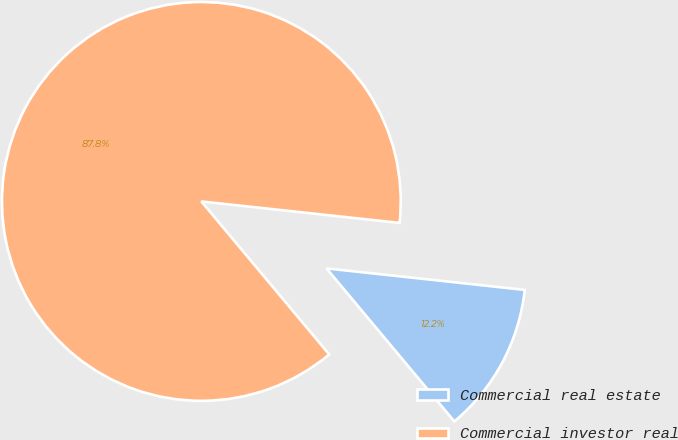<chart> <loc_0><loc_0><loc_500><loc_500><pie_chart><fcel>Commercial real estate<fcel>Commercial investor real<nl><fcel>12.2%<fcel>87.8%<nl></chart> 